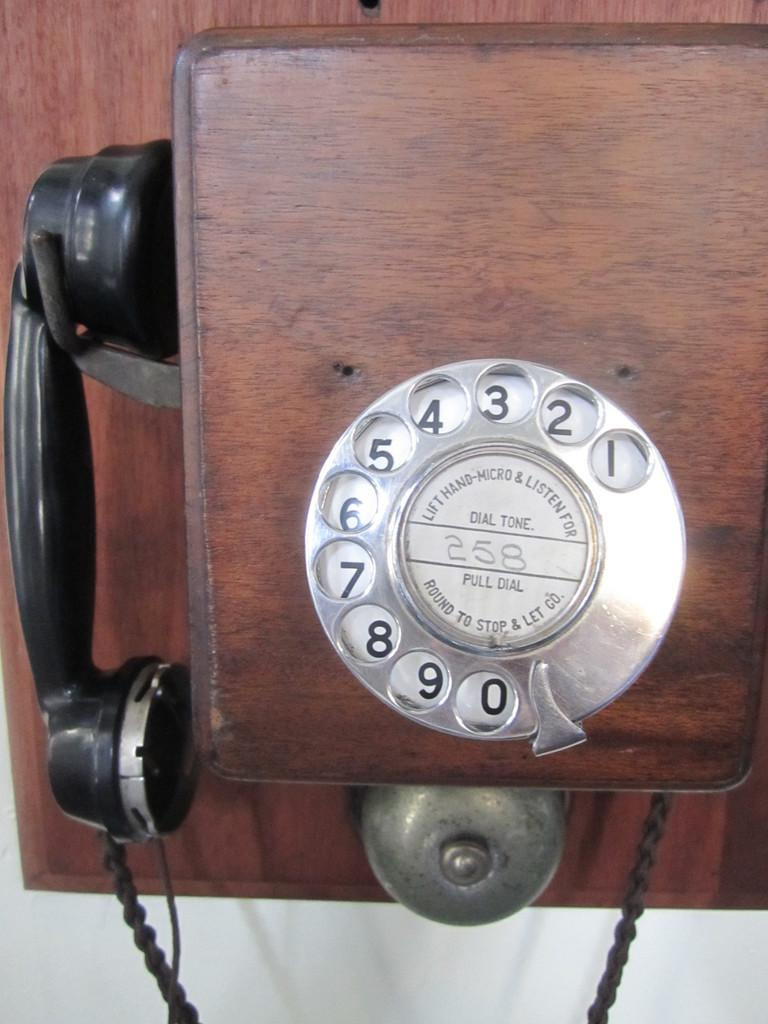<image>
Describe the image concisely. an old fashioned dial phone with the word Dial Tone on the dial 